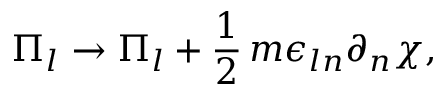<formula> <loc_0><loc_0><loc_500><loc_500>\Pi _ { l } \rightarrow \Pi _ { l } + \frac { 1 } { 2 } \, m \epsilon _ { \ln } \partial _ { n } \chi ,</formula> 